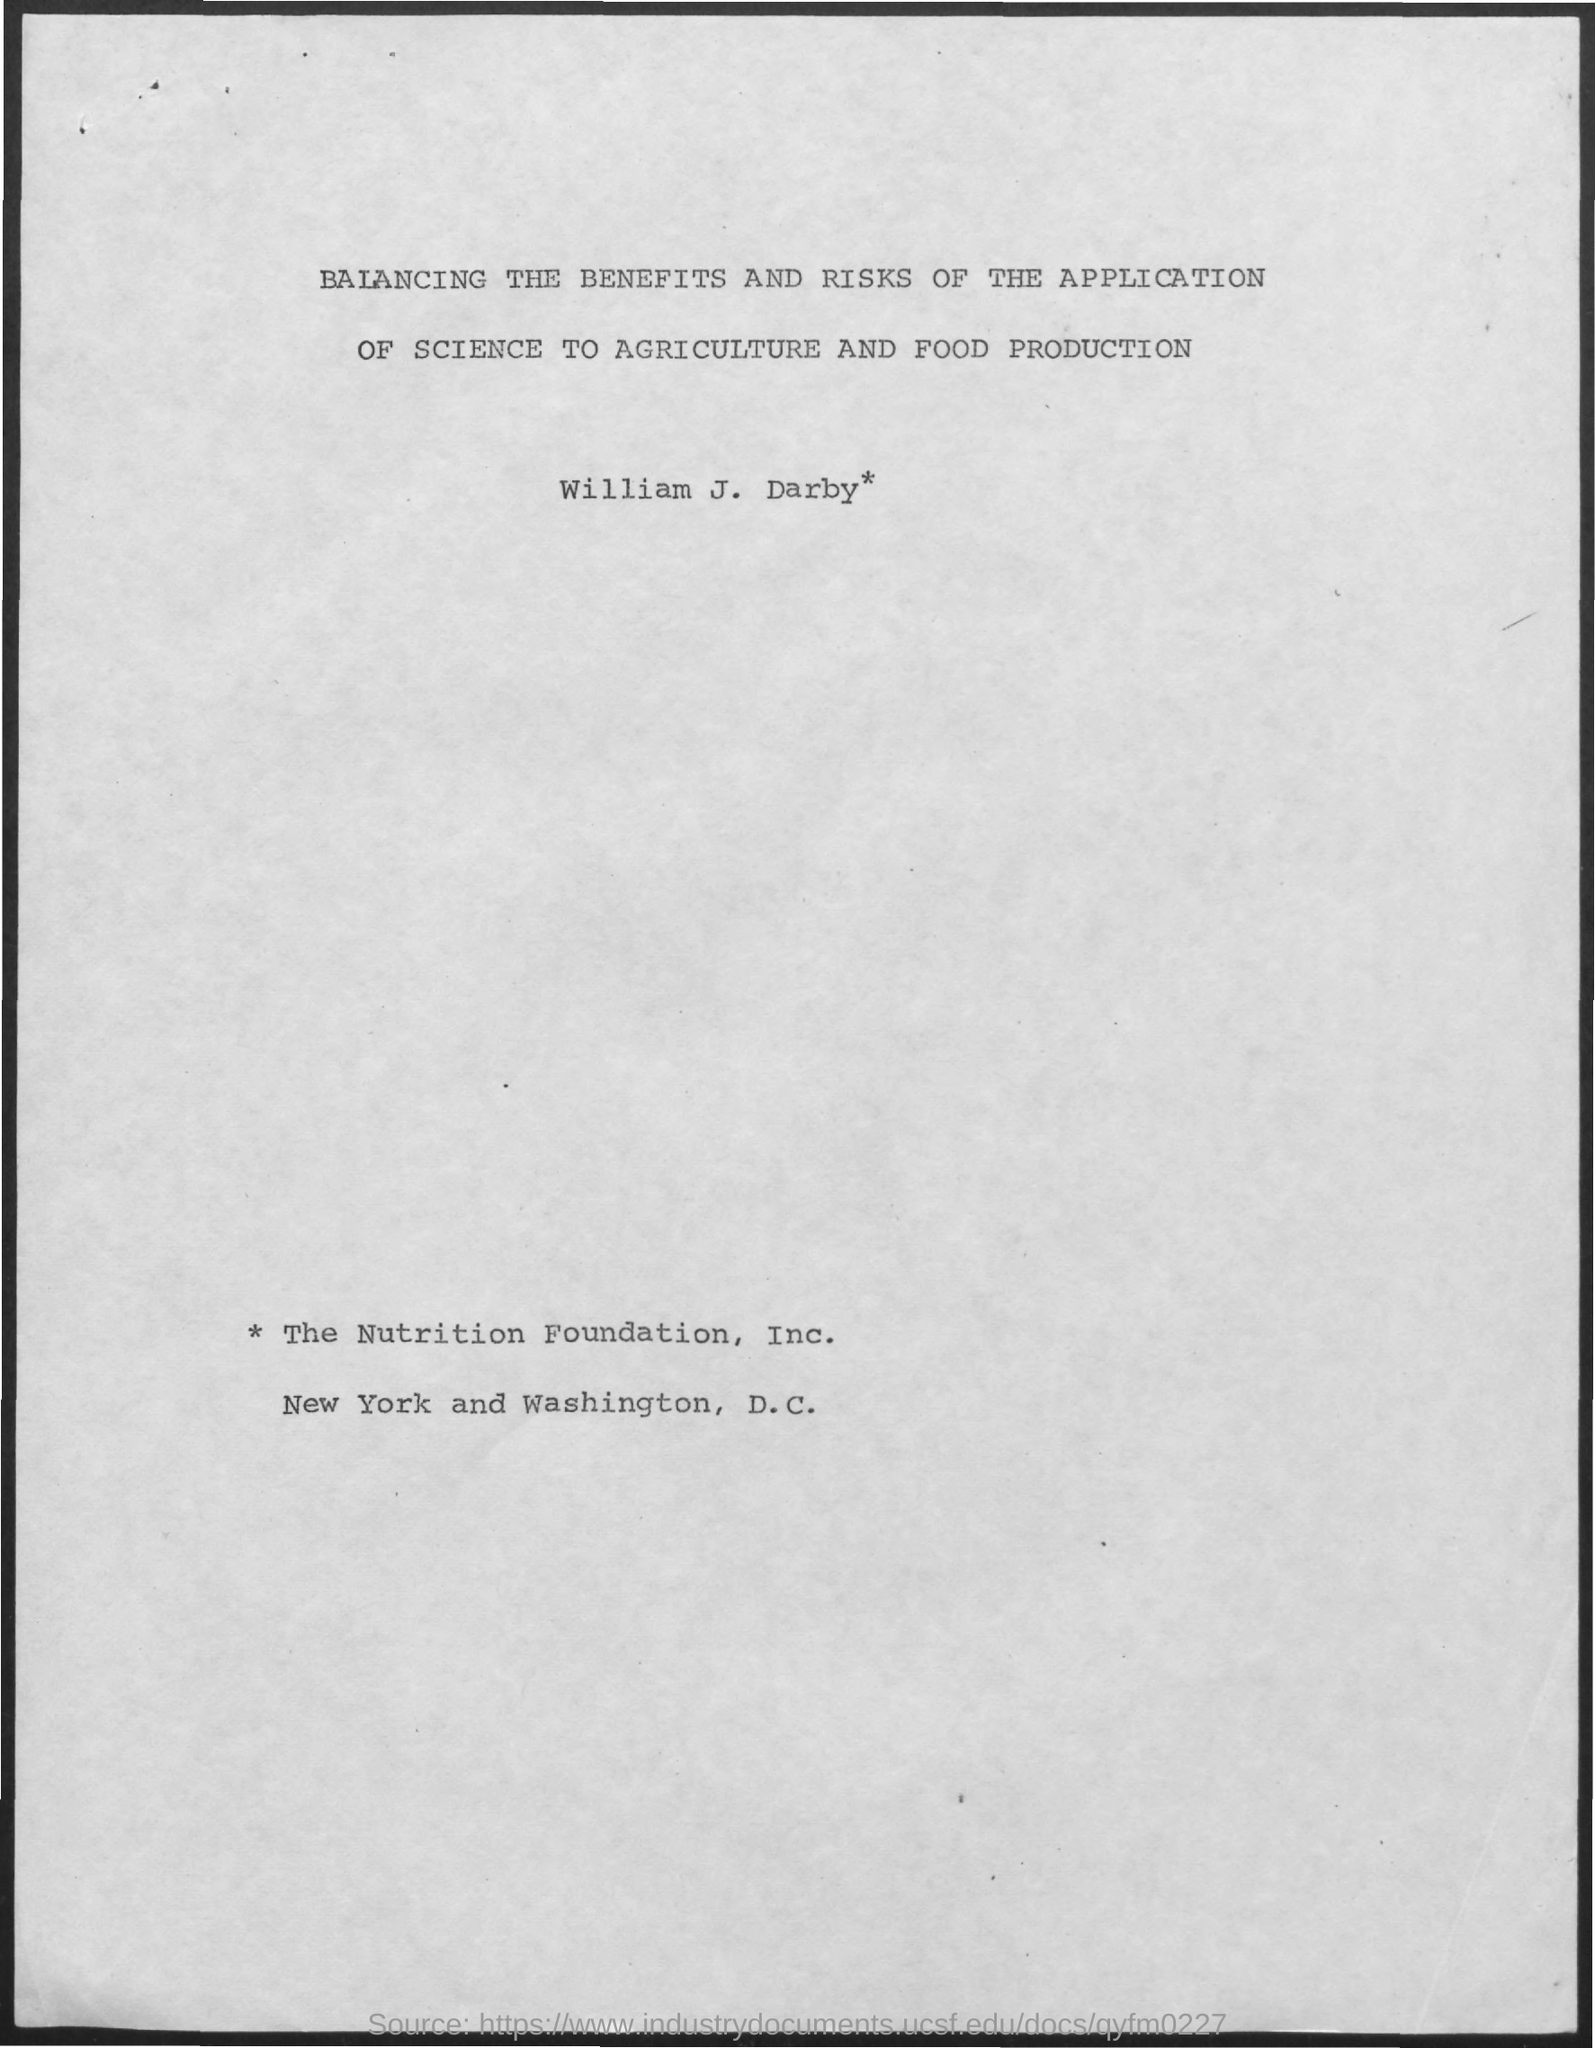List a handful of essential elements in this visual. The title of the document is "The Balancing Act: Evaluating the Benefits and Risks of Applying Science to Agriculture and Food Production". The person mentioned in the document is named William J. Darby. 